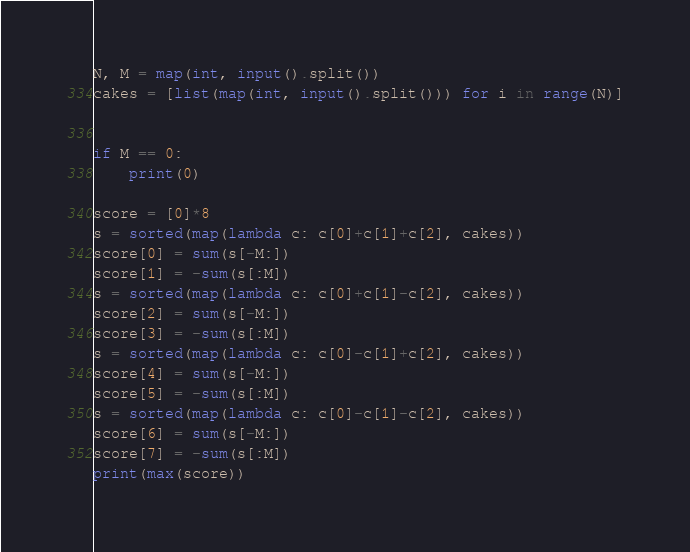Convert code to text. <code><loc_0><loc_0><loc_500><loc_500><_Python_>N, M = map(int, input().split())
cakes = [list(map(int, input().split())) for i in range(N)]


if M == 0:
    print(0)

score = [0]*8
s = sorted(map(lambda c: c[0]+c[1]+c[2], cakes))
score[0] = sum(s[-M:])
score[1] = -sum(s[:M])
s = sorted(map(lambda c: c[0]+c[1]-c[2], cakes))
score[2] = sum(s[-M:])
score[3] = -sum(s[:M])
s = sorted(map(lambda c: c[0]-c[1]+c[2], cakes))
score[4] = sum(s[-M:])
score[5] = -sum(s[:M])
s = sorted(map(lambda c: c[0]-c[1]-c[2], cakes))
score[6] = sum(s[-M:])
score[7] = -sum(s[:M])
print(max(score))</code> 